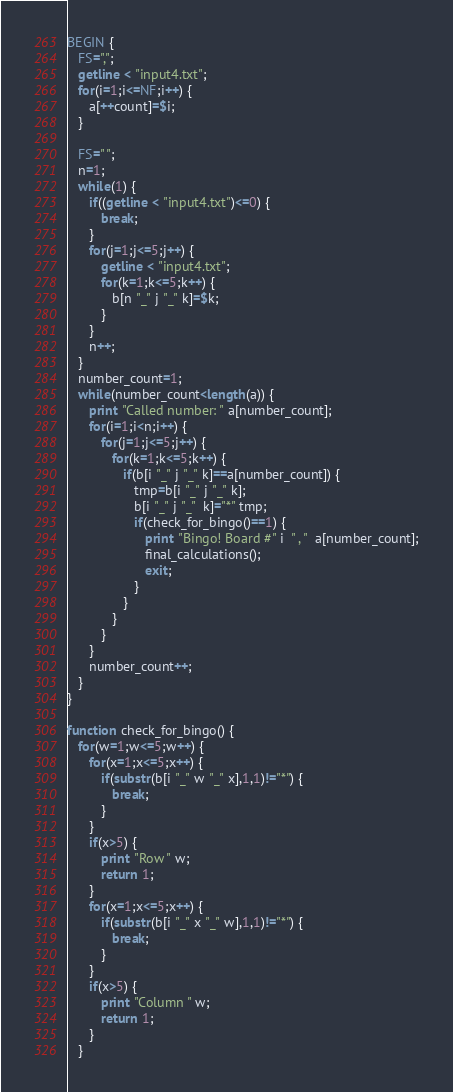<code> <loc_0><loc_0><loc_500><loc_500><_Awk_>BEGIN {
   FS=",";
   getline < "input4.txt";
   for(i=1;i<=NF;i++) {
      a[++count]=$i;
   }
   
   FS=" ";
   n=1;
   while(1) {
      if((getline < "input4.txt")<=0) {
         break;
      }
      for(j=1;j<=5;j++) {
         getline < "input4.txt";
         for(k=1;k<=5;k++) {
            b[n "_" j "_" k]=$k;
         }
      }
      n++;
   }
   number_count=1;
   while(number_count<length(a)) {
      print "Called number: " a[number_count];
      for(i=1;i<n;i++) {
         for(j=1;j<=5;j++) {
            for(k=1;k<=5;k++) {
               if(b[i "_" j "_" k]==a[number_count]) {
                  tmp=b[i "_" j "_" k];
                  b[i "_" j "_"  k]="*" tmp;
                  if(check_for_bingo()==1) {
                     print "Bingo! Board #" i  " , "  a[number_count];
                     final_calculations();
                     exit;
                  }
               }
            }
         }
      }
      number_count++;
   }
}

function check_for_bingo() {
   for(w=1;w<=5;w++) {
      for(x=1;x<=5;x++) {
         if(substr(b[i "_" w "_" x],1,1)!="*") {
            break;
         }
      }
      if(x>5) {
         print "Row " w;
         return 1;
      }
      for(x=1;x<=5;x++) {
         if(substr(b[i "_" x "_" w],1,1)!="*") {
            break;
         }
      }
      if(x>5) {
         print "Column " w;
         return 1;
      }
   }</code> 